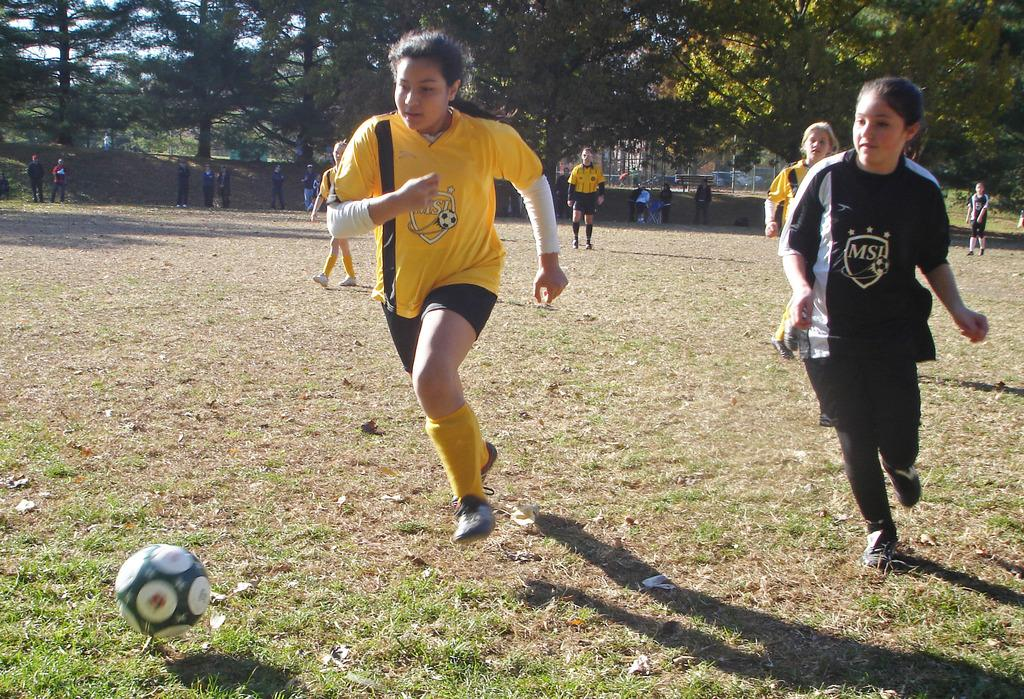How many women are present in the image? There are two women in the image. What are the women doing in the image? The women are running and attempting to hit a ball. What can be seen in the background of the image? There are trees and people in the background of the image. What type of approval system is in place for the women in the image? There is no mention of an approval system in the image; the women are simply running and attempting to hit a ball. 